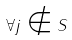Convert formula to latex. <formula><loc_0><loc_0><loc_500><loc_500>\forall j \notin S</formula> 